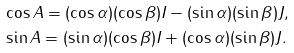<formula> <loc_0><loc_0><loc_500><loc_500>& \cos { A } = ( \cos { \alpha } ) ( \cos { \beta } ) I - ( \sin { \alpha } ) ( \sin { \beta } ) J , \\ & \sin { A } = ( \sin { \alpha } ) ( \cos { \beta } ) I + ( \cos { \alpha } ) ( \sin { \beta } ) J .</formula> 